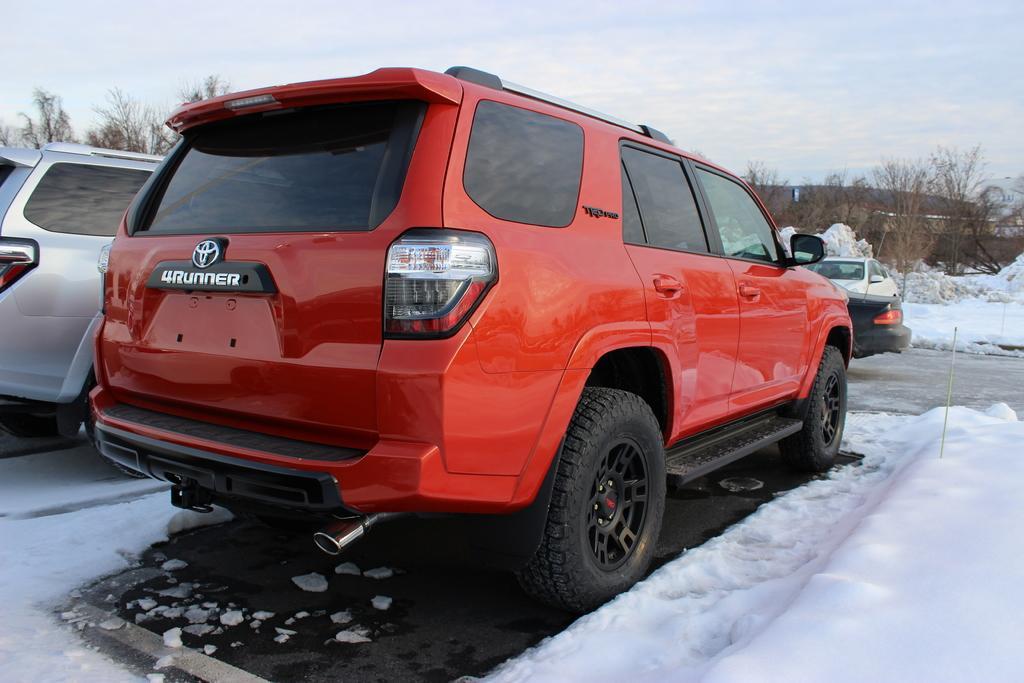Could you give a brief overview of what you see in this image? In the image we can see there are vehicles of different colors. Here we can see snow, trees and the sky. 